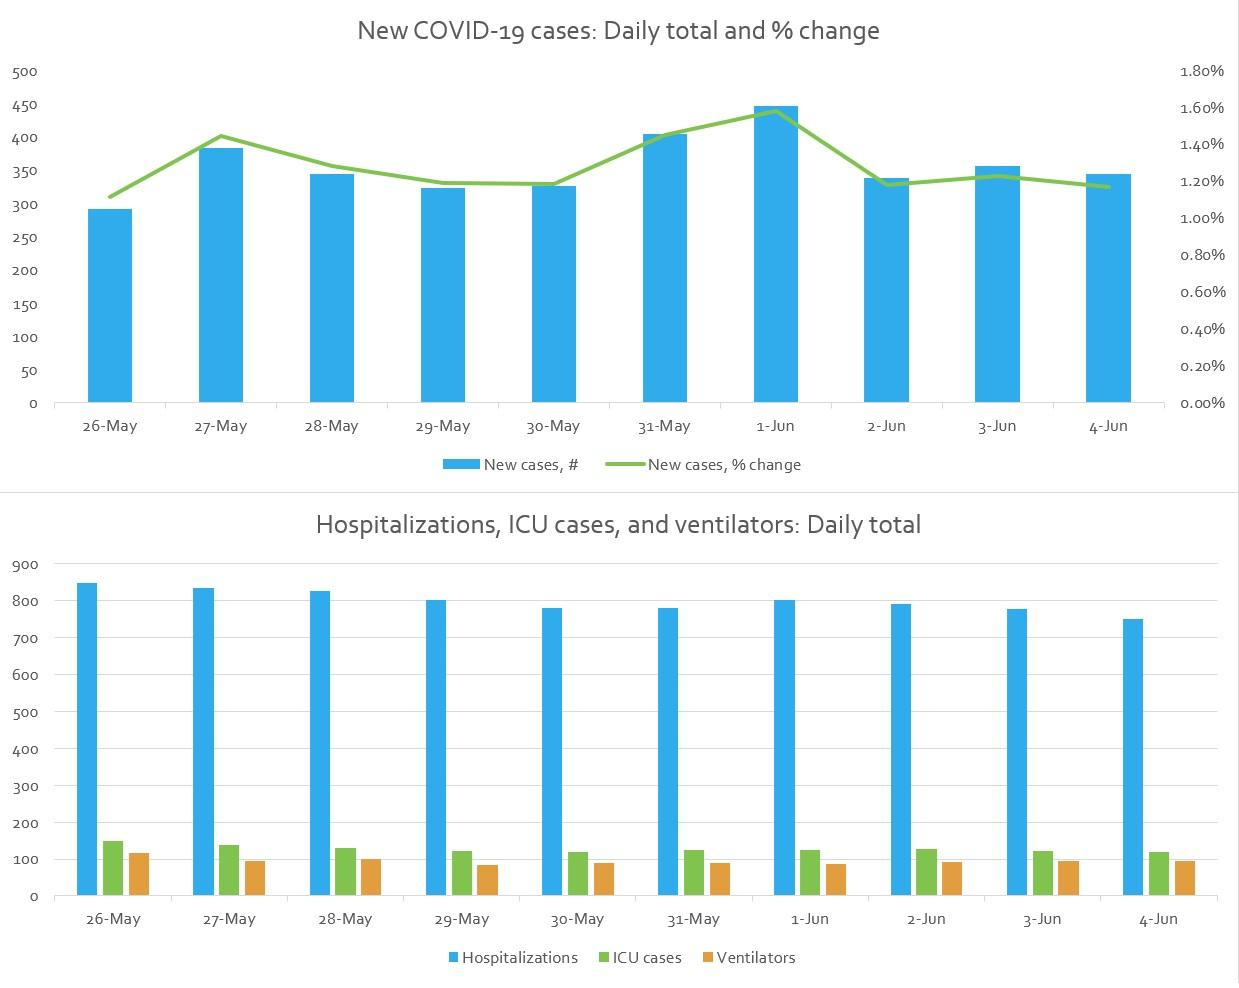Highlight a few significant elements in this photo. There were 10 days where the number of hospitalized cases was more than 700. The first bar chart shows the statistics of how many days are given. Specifically, the chart indicates that 10 days are provided. On May 29th and June 1st, there were 800 hospitalized cases. The hospitalization with the lowest number occurred on June 4th. During the week of May 26th to May 31st, the number of hospitalized cases exceeded 800 on three consecutive days, including May 26th, May 27th, and May 28th. 